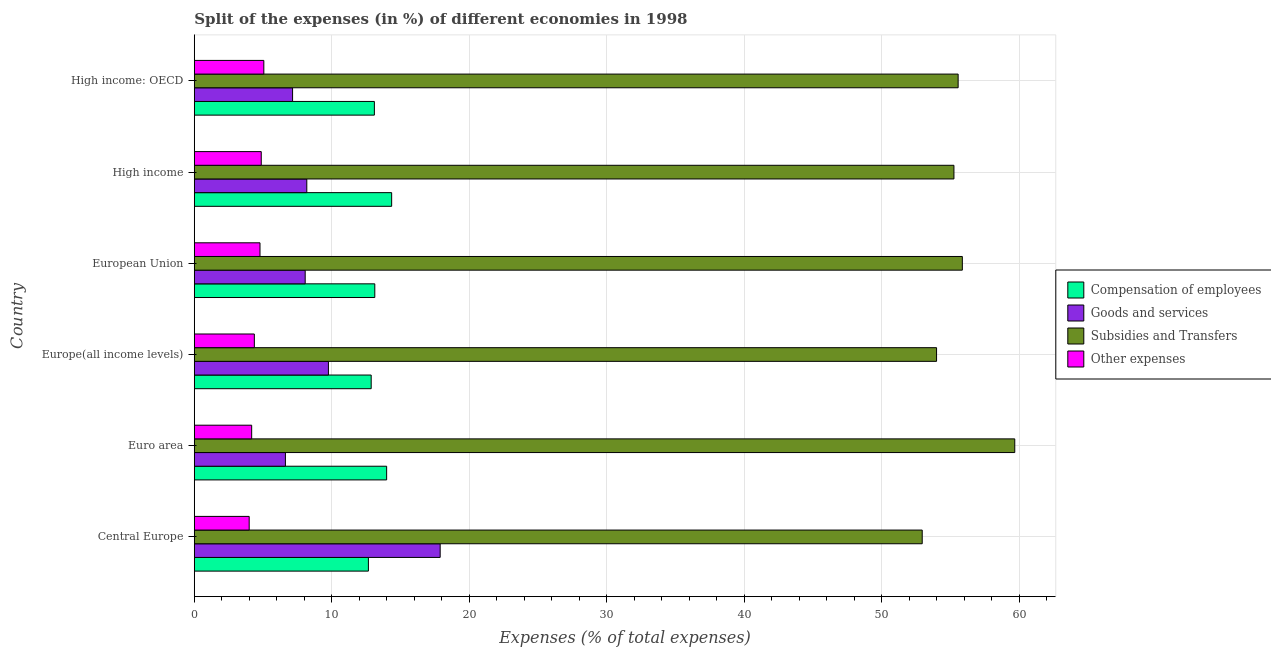How many groups of bars are there?
Offer a very short reply. 6. Are the number of bars per tick equal to the number of legend labels?
Your answer should be very brief. Yes. How many bars are there on the 6th tick from the bottom?
Keep it short and to the point. 4. What is the percentage of amount spent on compensation of employees in Euro area?
Offer a terse response. 13.99. Across all countries, what is the maximum percentage of amount spent on goods and services?
Your answer should be very brief. 17.88. Across all countries, what is the minimum percentage of amount spent on goods and services?
Keep it short and to the point. 6.63. In which country was the percentage of amount spent on other expenses maximum?
Offer a terse response. High income: OECD. In which country was the percentage of amount spent on subsidies minimum?
Make the answer very short. Central Europe. What is the total percentage of amount spent on goods and services in the graph?
Your answer should be compact. 57.67. What is the difference between the percentage of amount spent on subsidies in Central Europe and that in High income?
Offer a very short reply. -2.31. What is the difference between the percentage of amount spent on compensation of employees in Central Europe and the percentage of amount spent on goods and services in European Union?
Ensure brevity in your answer.  4.6. What is the average percentage of amount spent on other expenses per country?
Ensure brevity in your answer.  4.54. What is the difference between the percentage of amount spent on goods and services and percentage of amount spent on compensation of employees in Central Europe?
Offer a terse response. 5.22. What is the ratio of the percentage of amount spent on goods and services in High income to that in High income: OECD?
Make the answer very short. 1.15. What is the difference between the highest and the second highest percentage of amount spent on other expenses?
Your response must be concise. 0.19. What is the difference between the highest and the lowest percentage of amount spent on goods and services?
Give a very brief answer. 11.25. In how many countries, is the percentage of amount spent on subsidies greater than the average percentage of amount spent on subsidies taken over all countries?
Ensure brevity in your answer.  3. What does the 1st bar from the top in Euro area represents?
Ensure brevity in your answer.  Other expenses. What does the 1st bar from the bottom in European Union represents?
Keep it short and to the point. Compensation of employees. Is it the case that in every country, the sum of the percentage of amount spent on compensation of employees and percentage of amount spent on goods and services is greater than the percentage of amount spent on subsidies?
Make the answer very short. No. How many bars are there?
Keep it short and to the point. 24. How many countries are there in the graph?
Offer a terse response. 6. Does the graph contain any zero values?
Provide a short and direct response. No. Does the graph contain grids?
Keep it short and to the point. Yes. What is the title of the graph?
Your answer should be compact. Split of the expenses (in %) of different economies in 1998. Does "Quality of logistic services" appear as one of the legend labels in the graph?
Keep it short and to the point. No. What is the label or title of the X-axis?
Make the answer very short. Expenses (% of total expenses). What is the Expenses (% of total expenses) of Compensation of employees in Central Europe?
Provide a short and direct response. 12.67. What is the Expenses (% of total expenses) of Goods and services in Central Europe?
Ensure brevity in your answer.  17.88. What is the Expenses (% of total expenses) of Subsidies and Transfers in Central Europe?
Your answer should be compact. 52.94. What is the Expenses (% of total expenses) in Other expenses in Central Europe?
Provide a short and direct response. 3.99. What is the Expenses (% of total expenses) in Compensation of employees in Euro area?
Your answer should be compact. 13.99. What is the Expenses (% of total expenses) in Goods and services in Euro area?
Provide a succinct answer. 6.63. What is the Expenses (% of total expenses) in Subsidies and Transfers in Euro area?
Your response must be concise. 59.67. What is the Expenses (% of total expenses) of Other expenses in Euro area?
Offer a very short reply. 4.18. What is the Expenses (% of total expenses) of Compensation of employees in Europe(all income levels)?
Provide a succinct answer. 12.87. What is the Expenses (% of total expenses) in Goods and services in Europe(all income levels)?
Your response must be concise. 9.76. What is the Expenses (% of total expenses) of Subsidies and Transfers in Europe(all income levels)?
Offer a very short reply. 53.99. What is the Expenses (% of total expenses) in Other expenses in Europe(all income levels)?
Give a very brief answer. 4.37. What is the Expenses (% of total expenses) of Compensation of employees in European Union?
Provide a succinct answer. 13.13. What is the Expenses (% of total expenses) in Goods and services in European Union?
Provide a short and direct response. 8.07. What is the Expenses (% of total expenses) of Subsidies and Transfers in European Union?
Make the answer very short. 55.86. What is the Expenses (% of total expenses) in Other expenses in European Union?
Make the answer very short. 4.78. What is the Expenses (% of total expenses) in Compensation of employees in High income?
Your response must be concise. 14.36. What is the Expenses (% of total expenses) in Goods and services in High income?
Make the answer very short. 8.18. What is the Expenses (% of total expenses) of Subsidies and Transfers in High income?
Offer a very short reply. 55.25. What is the Expenses (% of total expenses) in Other expenses in High income?
Provide a short and direct response. 4.87. What is the Expenses (% of total expenses) of Compensation of employees in High income: OECD?
Offer a terse response. 13.1. What is the Expenses (% of total expenses) in Goods and services in High income: OECD?
Give a very brief answer. 7.15. What is the Expenses (% of total expenses) in Subsidies and Transfers in High income: OECD?
Ensure brevity in your answer.  55.56. What is the Expenses (% of total expenses) of Other expenses in High income: OECD?
Offer a very short reply. 5.06. Across all countries, what is the maximum Expenses (% of total expenses) of Compensation of employees?
Your answer should be very brief. 14.36. Across all countries, what is the maximum Expenses (% of total expenses) in Goods and services?
Your answer should be very brief. 17.88. Across all countries, what is the maximum Expenses (% of total expenses) in Subsidies and Transfers?
Give a very brief answer. 59.67. Across all countries, what is the maximum Expenses (% of total expenses) in Other expenses?
Keep it short and to the point. 5.06. Across all countries, what is the minimum Expenses (% of total expenses) in Compensation of employees?
Make the answer very short. 12.67. Across all countries, what is the minimum Expenses (% of total expenses) in Goods and services?
Your answer should be very brief. 6.63. Across all countries, what is the minimum Expenses (% of total expenses) of Subsidies and Transfers?
Keep it short and to the point. 52.94. Across all countries, what is the minimum Expenses (% of total expenses) of Other expenses?
Offer a terse response. 3.99. What is the total Expenses (% of total expenses) of Compensation of employees in the graph?
Offer a very short reply. 80.11. What is the total Expenses (% of total expenses) of Goods and services in the graph?
Your answer should be very brief. 57.67. What is the total Expenses (% of total expenses) in Subsidies and Transfers in the graph?
Your answer should be compact. 333.27. What is the total Expenses (% of total expenses) in Other expenses in the graph?
Ensure brevity in your answer.  27.25. What is the difference between the Expenses (% of total expenses) in Compensation of employees in Central Europe and that in Euro area?
Provide a short and direct response. -1.33. What is the difference between the Expenses (% of total expenses) of Goods and services in Central Europe and that in Euro area?
Provide a short and direct response. 11.25. What is the difference between the Expenses (% of total expenses) of Subsidies and Transfers in Central Europe and that in Euro area?
Provide a succinct answer. -6.73. What is the difference between the Expenses (% of total expenses) in Other expenses in Central Europe and that in Euro area?
Your answer should be very brief. -0.18. What is the difference between the Expenses (% of total expenses) in Compensation of employees in Central Europe and that in Europe(all income levels)?
Make the answer very short. -0.2. What is the difference between the Expenses (% of total expenses) in Goods and services in Central Europe and that in Europe(all income levels)?
Provide a short and direct response. 8.13. What is the difference between the Expenses (% of total expenses) in Subsidies and Transfers in Central Europe and that in Europe(all income levels)?
Provide a short and direct response. -1.04. What is the difference between the Expenses (% of total expenses) in Other expenses in Central Europe and that in Europe(all income levels)?
Provide a short and direct response. -0.38. What is the difference between the Expenses (% of total expenses) of Compensation of employees in Central Europe and that in European Union?
Keep it short and to the point. -0.46. What is the difference between the Expenses (% of total expenses) of Goods and services in Central Europe and that in European Union?
Make the answer very short. 9.82. What is the difference between the Expenses (% of total expenses) of Subsidies and Transfers in Central Europe and that in European Union?
Offer a terse response. -2.92. What is the difference between the Expenses (% of total expenses) in Other expenses in Central Europe and that in European Union?
Your answer should be compact. -0.79. What is the difference between the Expenses (% of total expenses) in Compensation of employees in Central Europe and that in High income?
Provide a succinct answer. -1.69. What is the difference between the Expenses (% of total expenses) of Goods and services in Central Europe and that in High income?
Offer a very short reply. 9.7. What is the difference between the Expenses (% of total expenses) of Subsidies and Transfers in Central Europe and that in High income?
Your answer should be compact. -2.31. What is the difference between the Expenses (% of total expenses) in Other expenses in Central Europe and that in High income?
Your response must be concise. -0.88. What is the difference between the Expenses (% of total expenses) in Compensation of employees in Central Europe and that in High income: OECD?
Your answer should be very brief. -0.43. What is the difference between the Expenses (% of total expenses) of Goods and services in Central Europe and that in High income: OECD?
Your response must be concise. 10.73. What is the difference between the Expenses (% of total expenses) of Subsidies and Transfers in Central Europe and that in High income: OECD?
Provide a short and direct response. -2.61. What is the difference between the Expenses (% of total expenses) of Other expenses in Central Europe and that in High income: OECD?
Make the answer very short. -1.07. What is the difference between the Expenses (% of total expenses) of Compensation of employees in Euro area and that in Europe(all income levels)?
Ensure brevity in your answer.  1.12. What is the difference between the Expenses (% of total expenses) in Goods and services in Euro area and that in Europe(all income levels)?
Make the answer very short. -3.13. What is the difference between the Expenses (% of total expenses) of Subsidies and Transfers in Euro area and that in Europe(all income levels)?
Your response must be concise. 5.69. What is the difference between the Expenses (% of total expenses) in Other expenses in Euro area and that in Europe(all income levels)?
Offer a very short reply. -0.19. What is the difference between the Expenses (% of total expenses) of Compensation of employees in Euro area and that in European Union?
Offer a terse response. 0.86. What is the difference between the Expenses (% of total expenses) of Goods and services in Euro area and that in European Union?
Your response must be concise. -1.44. What is the difference between the Expenses (% of total expenses) of Subsidies and Transfers in Euro area and that in European Union?
Ensure brevity in your answer.  3.81. What is the difference between the Expenses (% of total expenses) of Other expenses in Euro area and that in European Union?
Provide a succinct answer. -0.61. What is the difference between the Expenses (% of total expenses) in Compensation of employees in Euro area and that in High income?
Your answer should be very brief. -0.36. What is the difference between the Expenses (% of total expenses) of Goods and services in Euro area and that in High income?
Offer a terse response. -1.55. What is the difference between the Expenses (% of total expenses) of Subsidies and Transfers in Euro area and that in High income?
Keep it short and to the point. 4.42. What is the difference between the Expenses (% of total expenses) in Other expenses in Euro area and that in High income?
Offer a very short reply. -0.7. What is the difference between the Expenses (% of total expenses) of Compensation of employees in Euro area and that in High income: OECD?
Provide a short and direct response. 0.89. What is the difference between the Expenses (% of total expenses) in Goods and services in Euro area and that in High income: OECD?
Offer a very short reply. -0.52. What is the difference between the Expenses (% of total expenses) of Subsidies and Transfers in Euro area and that in High income: OECD?
Your answer should be compact. 4.12. What is the difference between the Expenses (% of total expenses) in Other expenses in Euro area and that in High income: OECD?
Offer a very short reply. -0.88. What is the difference between the Expenses (% of total expenses) of Compensation of employees in Europe(all income levels) and that in European Union?
Your response must be concise. -0.26. What is the difference between the Expenses (% of total expenses) in Goods and services in Europe(all income levels) and that in European Union?
Offer a terse response. 1.69. What is the difference between the Expenses (% of total expenses) of Subsidies and Transfers in Europe(all income levels) and that in European Union?
Ensure brevity in your answer.  -1.87. What is the difference between the Expenses (% of total expenses) in Other expenses in Europe(all income levels) and that in European Union?
Make the answer very short. -0.41. What is the difference between the Expenses (% of total expenses) in Compensation of employees in Europe(all income levels) and that in High income?
Your answer should be very brief. -1.49. What is the difference between the Expenses (% of total expenses) of Goods and services in Europe(all income levels) and that in High income?
Make the answer very short. 1.57. What is the difference between the Expenses (% of total expenses) of Subsidies and Transfers in Europe(all income levels) and that in High income?
Make the answer very short. -1.26. What is the difference between the Expenses (% of total expenses) in Other expenses in Europe(all income levels) and that in High income?
Provide a short and direct response. -0.5. What is the difference between the Expenses (% of total expenses) in Compensation of employees in Europe(all income levels) and that in High income: OECD?
Offer a very short reply. -0.23. What is the difference between the Expenses (% of total expenses) of Goods and services in Europe(all income levels) and that in High income: OECD?
Offer a very short reply. 2.61. What is the difference between the Expenses (% of total expenses) of Subsidies and Transfers in Europe(all income levels) and that in High income: OECD?
Give a very brief answer. -1.57. What is the difference between the Expenses (% of total expenses) of Other expenses in Europe(all income levels) and that in High income: OECD?
Keep it short and to the point. -0.69. What is the difference between the Expenses (% of total expenses) in Compensation of employees in European Union and that in High income?
Give a very brief answer. -1.23. What is the difference between the Expenses (% of total expenses) of Goods and services in European Union and that in High income?
Make the answer very short. -0.12. What is the difference between the Expenses (% of total expenses) in Subsidies and Transfers in European Union and that in High income?
Offer a very short reply. 0.61. What is the difference between the Expenses (% of total expenses) of Other expenses in European Union and that in High income?
Offer a terse response. -0.09. What is the difference between the Expenses (% of total expenses) in Compensation of employees in European Union and that in High income: OECD?
Your response must be concise. 0.03. What is the difference between the Expenses (% of total expenses) in Goods and services in European Union and that in High income: OECD?
Offer a terse response. 0.92. What is the difference between the Expenses (% of total expenses) of Subsidies and Transfers in European Union and that in High income: OECD?
Ensure brevity in your answer.  0.31. What is the difference between the Expenses (% of total expenses) of Other expenses in European Union and that in High income: OECD?
Offer a very short reply. -0.28. What is the difference between the Expenses (% of total expenses) of Compensation of employees in High income and that in High income: OECD?
Provide a succinct answer. 1.26. What is the difference between the Expenses (% of total expenses) of Goods and services in High income and that in High income: OECD?
Provide a short and direct response. 1.03. What is the difference between the Expenses (% of total expenses) in Subsidies and Transfers in High income and that in High income: OECD?
Your answer should be very brief. -0.31. What is the difference between the Expenses (% of total expenses) in Other expenses in High income and that in High income: OECD?
Make the answer very short. -0.19. What is the difference between the Expenses (% of total expenses) in Compensation of employees in Central Europe and the Expenses (% of total expenses) in Goods and services in Euro area?
Offer a terse response. 6.04. What is the difference between the Expenses (% of total expenses) of Compensation of employees in Central Europe and the Expenses (% of total expenses) of Subsidies and Transfers in Euro area?
Provide a short and direct response. -47.01. What is the difference between the Expenses (% of total expenses) in Compensation of employees in Central Europe and the Expenses (% of total expenses) in Other expenses in Euro area?
Provide a short and direct response. 8.49. What is the difference between the Expenses (% of total expenses) of Goods and services in Central Europe and the Expenses (% of total expenses) of Subsidies and Transfers in Euro area?
Give a very brief answer. -41.79. What is the difference between the Expenses (% of total expenses) in Goods and services in Central Europe and the Expenses (% of total expenses) in Other expenses in Euro area?
Make the answer very short. 13.71. What is the difference between the Expenses (% of total expenses) in Subsidies and Transfers in Central Europe and the Expenses (% of total expenses) in Other expenses in Euro area?
Provide a succinct answer. 48.77. What is the difference between the Expenses (% of total expenses) in Compensation of employees in Central Europe and the Expenses (% of total expenses) in Goods and services in Europe(all income levels)?
Your answer should be compact. 2.91. What is the difference between the Expenses (% of total expenses) of Compensation of employees in Central Europe and the Expenses (% of total expenses) of Subsidies and Transfers in Europe(all income levels)?
Your answer should be compact. -41.32. What is the difference between the Expenses (% of total expenses) in Compensation of employees in Central Europe and the Expenses (% of total expenses) in Other expenses in Europe(all income levels)?
Ensure brevity in your answer.  8.3. What is the difference between the Expenses (% of total expenses) in Goods and services in Central Europe and the Expenses (% of total expenses) in Subsidies and Transfers in Europe(all income levels)?
Keep it short and to the point. -36.1. What is the difference between the Expenses (% of total expenses) of Goods and services in Central Europe and the Expenses (% of total expenses) of Other expenses in Europe(all income levels)?
Offer a terse response. 13.51. What is the difference between the Expenses (% of total expenses) in Subsidies and Transfers in Central Europe and the Expenses (% of total expenses) in Other expenses in Europe(all income levels)?
Offer a terse response. 48.57. What is the difference between the Expenses (% of total expenses) of Compensation of employees in Central Europe and the Expenses (% of total expenses) of Goods and services in European Union?
Offer a terse response. 4.6. What is the difference between the Expenses (% of total expenses) in Compensation of employees in Central Europe and the Expenses (% of total expenses) in Subsidies and Transfers in European Union?
Provide a succinct answer. -43.2. What is the difference between the Expenses (% of total expenses) in Compensation of employees in Central Europe and the Expenses (% of total expenses) in Other expenses in European Union?
Your answer should be compact. 7.88. What is the difference between the Expenses (% of total expenses) in Goods and services in Central Europe and the Expenses (% of total expenses) in Subsidies and Transfers in European Union?
Provide a short and direct response. -37.98. What is the difference between the Expenses (% of total expenses) in Goods and services in Central Europe and the Expenses (% of total expenses) in Other expenses in European Union?
Give a very brief answer. 13.1. What is the difference between the Expenses (% of total expenses) in Subsidies and Transfers in Central Europe and the Expenses (% of total expenses) in Other expenses in European Union?
Provide a short and direct response. 48.16. What is the difference between the Expenses (% of total expenses) of Compensation of employees in Central Europe and the Expenses (% of total expenses) of Goods and services in High income?
Offer a very short reply. 4.48. What is the difference between the Expenses (% of total expenses) in Compensation of employees in Central Europe and the Expenses (% of total expenses) in Subsidies and Transfers in High income?
Keep it short and to the point. -42.58. What is the difference between the Expenses (% of total expenses) of Compensation of employees in Central Europe and the Expenses (% of total expenses) of Other expenses in High income?
Provide a succinct answer. 7.79. What is the difference between the Expenses (% of total expenses) of Goods and services in Central Europe and the Expenses (% of total expenses) of Subsidies and Transfers in High income?
Give a very brief answer. -37.37. What is the difference between the Expenses (% of total expenses) of Goods and services in Central Europe and the Expenses (% of total expenses) of Other expenses in High income?
Give a very brief answer. 13.01. What is the difference between the Expenses (% of total expenses) of Subsidies and Transfers in Central Europe and the Expenses (% of total expenses) of Other expenses in High income?
Give a very brief answer. 48.07. What is the difference between the Expenses (% of total expenses) in Compensation of employees in Central Europe and the Expenses (% of total expenses) in Goods and services in High income: OECD?
Provide a short and direct response. 5.51. What is the difference between the Expenses (% of total expenses) in Compensation of employees in Central Europe and the Expenses (% of total expenses) in Subsidies and Transfers in High income: OECD?
Ensure brevity in your answer.  -42.89. What is the difference between the Expenses (% of total expenses) of Compensation of employees in Central Europe and the Expenses (% of total expenses) of Other expenses in High income: OECD?
Give a very brief answer. 7.61. What is the difference between the Expenses (% of total expenses) of Goods and services in Central Europe and the Expenses (% of total expenses) of Subsidies and Transfers in High income: OECD?
Your answer should be compact. -37.67. What is the difference between the Expenses (% of total expenses) of Goods and services in Central Europe and the Expenses (% of total expenses) of Other expenses in High income: OECD?
Provide a short and direct response. 12.82. What is the difference between the Expenses (% of total expenses) in Subsidies and Transfers in Central Europe and the Expenses (% of total expenses) in Other expenses in High income: OECD?
Keep it short and to the point. 47.88. What is the difference between the Expenses (% of total expenses) in Compensation of employees in Euro area and the Expenses (% of total expenses) in Goods and services in Europe(all income levels)?
Your response must be concise. 4.23. What is the difference between the Expenses (% of total expenses) of Compensation of employees in Euro area and the Expenses (% of total expenses) of Subsidies and Transfers in Europe(all income levels)?
Keep it short and to the point. -39.99. What is the difference between the Expenses (% of total expenses) of Compensation of employees in Euro area and the Expenses (% of total expenses) of Other expenses in Europe(all income levels)?
Offer a terse response. 9.62. What is the difference between the Expenses (% of total expenses) in Goods and services in Euro area and the Expenses (% of total expenses) in Subsidies and Transfers in Europe(all income levels)?
Provide a short and direct response. -47.36. What is the difference between the Expenses (% of total expenses) in Goods and services in Euro area and the Expenses (% of total expenses) in Other expenses in Europe(all income levels)?
Your answer should be compact. 2.26. What is the difference between the Expenses (% of total expenses) in Subsidies and Transfers in Euro area and the Expenses (% of total expenses) in Other expenses in Europe(all income levels)?
Your answer should be compact. 55.3. What is the difference between the Expenses (% of total expenses) of Compensation of employees in Euro area and the Expenses (% of total expenses) of Goods and services in European Union?
Give a very brief answer. 5.92. What is the difference between the Expenses (% of total expenses) of Compensation of employees in Euro area and the Expenses (% of total expenses) of Subsidies and Transfers in European Union?
Offer a terse response. -41.87. What is the difference between the Expenses (% of total expenses) in Compensation of employees in Euro area and the Expenses (% of total expenses) in Other expenses in European Union?
Make the answer very short. 9.21. What is the difference between the Expenses (% of total expenses) of Goods and services in Euro area and the Expenses (% of total expenses) of Subsidies and Transfers in European Union?
Your answer should be very brief. -49.23. What is the difference between the Expenses (% of total expenses) in Goods and services in Euro area and the Expenses (% of total expenses) in Other expenses in European Union?
Make the answer very short. 1.85. What is the difference between the Expenses (% of total expenses) in Subsidies and Transfers in Euro area and the Expenses (% of total expenses) in Other expenses in European Union?
Make the answer very short. 54.89. What is the difference between the Expenses (% of total expenses) of Compensation of employees in Euro area and the Expenses (% of total expenses) of Goods and services in High income?
Offer a terse response. 5.81. What is the difference between the Expenses (% of total expenses) of Compensation of employees in Euro area and the Expenses (% of total expenses) of Subsidies and Transfers in High income?
Give a very brief answer. -41.26. What is the difference between the Expenses (% of total expenses) in Compensation of employees in Euro area and the Expenses (% of total expenses) in Other expenses in High income?
Keep it short and to the point. 9.12. What is the difference between the Expenses (% of total expenses) of Goods and services in Euro area and the Expenses (% of total expenses) of Subsidies and Transfers in High income?
Your answer should be compact. -48.62. What is the difference between the Expenses (% of total expenses) of Goods and services in Euro area and the Expenses (% of total expenses) of Other expenses in High income?
Offer a terse response. 1.76. What is the difference between the Expenses (% of total expenses) in Subsidies and Transfers in Euro area and the Expenses (% of total expenses) in Other expenses in High income?
Your response must be concise. 54.8. What is the difference between the Expenses (% of total expenses) in Compensation of employees in Euro area and the Expenses (% of total expenses) in Goods and services in High income: OECD?
Your answer should be compact. 6.84. What is the difference between the Expenses (% of total expenses) of Compensation of employees in Euro area and the Expenses (% of total expenses) of Subsidies and Transfers in High income: OECD?
Make the answer very short. -41.56. What is the difference between the Expenses (% of total expenses) in Compensation of employees in Euro area and the Expenses (% of total expenses) in Other expenses in High income: OECD?
Make the answer very short. 8.93. What is the difference between the Expenses (% of total expenses) in Goods and services in Euro area and the Expenses (% of total expenses) in Subsidies and Transfers in High income: OECD?
Your answer should be very brief. -48.93. What is the difference between the Expenses (% of total expenses) in Goods and services in Euro area and the Expenses (% of total expenses) in Other expenses in High income: OECD?
Your answer should be very brief. 1.57. What is the difference between the Expenses (% of total expenses) of Subsidies and Transfers in Euro area and the Expenses (% of total expenses) of Other expenses in High income: OECD?
Offer a very short reply. 54.61. What is the difference between the Expenses (% of total expenses) in Compensation of employees in Europe(all income levels) and the Expenses (% of total expenses) in Goods and services in European Union?
Make the answer very short. 4.8. What is the difference between the Expenses (% of total expenses) in Compensation of employees in Europe(all income levels) and the Expenses (% of total expenses) in Subsidies and Transfers in European Union?
Ensure brevity in your answer.  -42.99. What is the difference between the Expenses (% of total expenses) of Compensation of employees in Europe(all income levels) and the Expenses (% of total expenses) of Other expenses in European Union?
Ensure brevity in your answer.  8.09. What is the difference between the Expenses (% of total expenses) of Goods and services in Europe(all income levels) and the Expenses (% of total expenses) of Subsidies and Transfers in European Union?
Provide a succinct answer. -46.1. What is the difference between the Expenses (% of total expenses) in Goods and services in Europe(all income levels) and the Expenses (% of total expenses) in Other expenses in European Union?
Offer a terse response. 4.98. What is the difference between the Expenses (% of total expenses) in Subsidies and Transfers in Europe(all income levels) and the Expenses (% of total expenses) in Other expenses in European Union?
Your response must be concise. 49.21. What is the difference between the Expenses (% of total expenses) of Compensation of employees in Europe(all income levels) and the Expenses (% of total expenses) of Goods and services in High income?
Give a very brief answer. 4.68. What is the difference between the Expenses (% of total expenses) in Compensation of employees in Europe(all income levels) and the Expenses (% of total expenses) in Subsidies and Transfers in High income?
Ensure brevity in your answer.  -42.38. What is the difference between the Expenses (% of total expenses) in Compensation of employees in Europe(all income levels) and the Expenses (% of total expenses) in Other expenses in High income?
Keep it short and to the point. 8. What is the difference between the Expenses (% of total expenses) of Goods and services in Europe(all income levels) and the Expenses (% of total expenses) of Subsidies and Transfers in High income?
Give a very brief answer. -45.49. What is the difference between the Expenses (% of total expenses) of Goods and services in Europe(all income levels) and the Expenses (% of total expenses) of Other expenses in High income?
Your response must be concise. 4.89. What is the difference between the Expenses (% of total expenses) of Subsidies and Transfers in Europe(all income levels) and the Expenses (% of total expenses) of Other expenses in High income?
Your answer should be compact. 49.12. What is the difference between the Expenses (% of total expenses) in Compensation of employees in Europe(all income levels) and the Expenses (% of total expenses) in Goods and services in High income: OECD?
Ensure brevity in your answer.  5.72. What is the difference between the Expenses (% of total expenses) of Compensation of employees in Europe(all income levels) and the Expenses (% of total expenses) of Subsidies and Transfers in High income: OECD?
Give a very brief answer. -42.69. What is the difference between the Expenses (% of total expenses) of Compensation of employees in Europe(all income levels) and the Expenses (% of total expenses) of Other expenses in High income: OECD?
Ensure brevity in your answer.  7.81. What is the difference between the Expenses (% of total expenses) in Goods and services in Europe(all income levels) and the Expenses (% of total expenses) in Subsidies and Transfers in High income: OECD?
Your response must be concise. -45.8. What is the difference between the Expenses (% of total expenses) in Goods and services in Europe(all income levels) and the Expenses (% of total expenses) in Other expenses in High income: OECD?
Your answer should be compact. 4.7. What is the difference between the Expenses (% of total expenses) of Subsidies and Transfers in Europe(all income levels) and the Expenses (% of total expenses) of Other expenses in High income: OECD?
Provide a succinct answer. 48.93. What is the difference between the Expenses (% of total expenses) in Compensation of employees in European Union and the Expenses (% of total expenses) in Goods and services in High income?
Offer a very short reply. 4.94. What is the difference between the Expenses (% of total expenses) of Compensation of employees in European Union and the Expenses (% of total expenses) of Subsidies and Transfers in High income?
Keep it short and to the point. -42.12. What is the difference between the Expenses (% of total expenses) of Compensation of employees in European Union and the Expenses (% of total expenses) of Other expenses in High income?
Ensure brevity in your answer.  8.26. What is the difference between the Expenses (% of total expenses) of Goods and services in European Union and the Expenses (% of total expenses) of Subsidies and Transfers in High income?
Give a very brief answer. -47.18. What is the difference between the Expenses (% of total expenses) of Goods and services in European Union and the Expenses (% of total expenses) of Other expenses in High income?
Provide a succinct answer. 3.2. What is the difference between the Expenses (% of total expenses) in Subsidies and Transfers in European Union and the Expenses (% of total expenses) in Other expenses in High income?
Your answer should be compact. 50.99. What is the difference between the Expenses (% of total expenses) of Compensation of employees in European Union and the Expenses (% of total expenses) of Goods and services in High income: OECD?
Give a very brief answer. 5.98. What is the difference between the Expenses (% of total expenses) in Compensation of employees in European Union and the Expenses (% of total expenses) in Subsidies and Transfers in High income: OECD?
Offer a very short reply. -42.43. What is the difference between the Expenses (% of total expenses) in Compensation of employees in European Union and the Expenses (% of total expenses) in Other expenses in High income: OECD?
Keep it short and to the point. 8.07. What is the difference between the Expenses (% of total expenses) in Goods and services in European Union and the Expenses (% of total expenses) in Subsidies and Transfers in High income: OECD?
Provide a short and direct response. -47.49. What is the difference between the Expenses (% of total expenses) of Goods and services in European Union and the Expenses (% of total expenses) of Other expenses in High income: OECD?
Your response must be concise. 3.01. What is the difference between the Expenses (% of total expenses) of Subsidies and Transfers in European Union and the Expenses (% of total expenses) of Other expenses in High income: OECD?
Provide a succinct answer. 50.8. What is the difference between the Expenses (% of total expenses) of Compensation of employees in High income and the Expenses (% of total expenses) of Goods and services in High income: OECD?
Your response must be concise. 7.21. What is the difference between the Expenses (% of total expenses) of Compensation of employees in High income and the Expenses (% of total expenses) of Subsidies and Transfers in High income: OECD?
Provide a succinct answer. -41.2. What is the difference between the Expenses (% of total expenses) of Compensation of employees in High income and the Expenses (% of total expenses) of Other expenses in High income: OECD?
Make the answer very short. 9.3. What is the difference between the Expenses (% of total expenses) in Goods and services in High income and the Expenses (% of total expenses) in Subsidies and Transfers in High income: OECD?
Provide a short and direct response. -47.37. What is the difference between the Expenses (% of total expenses) in Goods and services in High income and the Expenses (% of total expenses) in Other expenses in High income: OECD?
Make the answer very short. 3.13. What is the difference between the Expenses (% of total expenses) of Subsidies and Transfers in High income and the Expenses (% of total expenses) of Other expenses in High income: OECD?
Your answer should be very brief. 50.19. What is the average Expenses (% of total expenses) in Compensation of employees per country?
Your response must be concise. 13.35. What is the average Expenses (% of total expenses) in Goods and services per country?
Provide a short and direct response. 9.61. What is the average Expenses (% of total expenses) of Subsidies and Transfers per country?
Ensure brevity in your answer.  55.54. What is the average Expenses (% of total expenses) in Other expenses per country?
Give a very brief answer. 4.54. What is the difference between the Expenses (% of total expenses) in Compensation of employees and Expenses (% of total expenses) in Goods and services in Central Europe?
Provide a succinct answer. -5.22. What is the difference between the Expenses (% of total expenses) of Compensation of employees and Expenses (% of total expenses) of Subsidies and Transfers in Central Europe?
Keep it short and to the point. -40.28. What is the difference between the Expenses (% of total expenses) of Compensation of employees and Expenses (% of total expenses) of Other expenses in Central Europe?
Provide a short and direct response. 8.67. What is the difference between the Expenses (% of total expenses) in Goods and services and Expenses (% of total expenses) in Subsidies and Transfers in Central Europe?
Give a very brief answer. -35.06. What is the difference between the Expenses (% of total expenses) of Goods and services and Expenses (% of total expenses) of Other expenses in Central Europe?
Your answer should be very brief. 13.89. What is the difference between the Expenses (% of total expenses) in Subsidies and Transfers and Expenses (% of total expenses) in Other expenses in Central Europe?
Your answer should be compact. 48.95. What is the difference between the Expenses (% of total expenses) of Compensation of employees and Expenses (% of total expenses) of Goods and services in Euro area?
Provide a succinct answer. 7.36. What is the difference between the Expenses (% of total expenses) in Compensation of employees and Expenses (% of total expenses) in Subsidies and Transfers in Euro area?
Ensure brevity in your answer.  -45.68. What is the difference between the Expenses (% of total expenses) in Compensation of employees and Expenses (% of total expenses) in Other expenses in Euro area?
Ensure brevity in your answer.  9.82. What is the difference between the Expenses (% of total expenses) of Goods and services and Expenses (% of total expenses) of Subsidies and Transfers in Euro area?
Keep it short and to the point. -53.04. What is the difference between the Expenses (% of total expenses) in Goods and services and Expenses (% of total expenses) in Other expenses in Euro area?
Your answer should be compact. 2.45. What is the difference between the Expenses (% of total expenses) in Subsidies and Transfers and Expenses (% of total expenses) in Other expenses in Euro area?
Ensure brevity in your answer.  55.5. What is the difference between the Expenses (% of total expenses) in Compensation of employees and Expenses (% of total expenses) in Goods and services in Europe(all income levels)?
Your response must be concise. 3.11. What is the difference between the Expenses (% of total expenses) in Compensation of employees and Expenses (% of total expenses) in Subsidies and Transfers in Europe(all income levels)?
Ensure brevity in your answer.  -41.12. What is the difference between the Expenses (% of total expenses) in Compensation of employees and Expenses (% of total expenses) in Other expenses in Europe(all income levels)?
Ensure brevity in your answer.  8.5. What is the difference between the Expenses (% of total expenses) in Goods and services and Expenses (% of total expenses) in Subsidies and Transfers in Europe(all income levels)?
Offer a terse response. -44.23. What is the difference between the Expenses (% of total expenses) in Goods and services and Expenses (% of total expenses) in Other expenses in Europe(all income levels)?
Your answer should be very brief. 5.39. What is the difference between the Expenses (% of total expenses) in Subsidies and Transfers and Expenses (% of total expenses) in Other expenses in Europe(all income levels)?
Keep it short and to the point. 49.62. What is the difference between the Expenses (% of total expenses) in Compensation of employees and Expenses (% of total expenses) in Goods and services in European Union?
Offer a terse response. 5.06. What is the difference between the Expenses (% of total expenses) of Compensation of employees and Expenses (% of total expenses) of Subsidies and Transfers in European Union?
Provide a succinct answer. -42.73. What is the difference between the Expenses (% of total expenses) in Compensation of employees and Expenses (% of total expenses) in Other expenses in European Union?
Ensure brevity in your answer.  8.35. What is the difference between the Expenses (% of total expenses) in Goods and services and Expenses (% of total expenses) in Subsidies and Transfers in European Union?
Give a very brief answer. -47.79. What is the difference between the Expenses (% of total expenses) in Goods and services and Expenses (% of total expenses) in Other expenses in European Union?
Provide a short and direct response. 3.29. What is the difference between the Expenses (% of total expenses) in Subsidies and Transfers and Expenses (% of total expenses) in Other expenses in European Union?
Your response must be concise. 51.08. What is the difference between the Expenses (% of total expenses) in Compensation of employees and Expenses (% of total expenses) in Goods and services in High income?
Offer a terse response. 6.17. What is the difference between the Expenses (% of total expenses) of Compensation of employees and Expenses (% of total expenses) of Subsidies and Transfers in High income?
Give a very brief answer. -40.89. What is the difference between the Expenses (% of total expenses) of Compensation of employees and Expenses (% of total expenses) of Other expenses in High income?
Give a very brief answer. 9.48. What is the difference between the Expenses (% of total expenses) of Goods and services and Expenses (% of total expenses) of Subsidies and Transfers in High income?
Offer a terse response. -47.07. What is the difference between the Expenses (% of total expenses) of Goods and services and Expenses (% of total expenses) of Other expenses in High income?
Your response must be concise. 3.31. What is the difference between the Expenses (% of total expenses) of Subsidies and Transfers and Expenses (% of total expenses) of Other expenses in High income?
Make the answer very short. 50.38. What is the difference between the Expenses (% of total expenses) in Compensation of employees and Expenses (% of total expenses) in Goods and services in High income: OECD?
Make the answer very short. 5.95. What is the difference between the Expenses (% of total expenses) of Compensation of employees and Expenses (% of total expenses) of Subsidies and Transfers in High income: OECD?
Your answer should be very brief. -42.46. What is the difference between the Expenses (% of total expenses) of Compensation of employees and Expenses (% of total expenses) of Other expenses in High income: OECD?
Your answer should be very brief. 8.04. What is the difference between the Expenses (% of total expenses) of Goods and services and Expenses (% of total expenses) of Subsidies and Transfers in High income: OECD?
Offer a very short reply. -48.4. What is the difference between the Expenses (% of total expenses) in Goods and services and Expenses (% of total expenses) in Other expenses in High income: OECD?
Provide a short and direct response. 2.09. What is the difference between the Expenses (% of total expenses) in Subsidies and Transfers and Expenses (% of total expenses) in Other expenses in High income: OECD?
Keep it short and to the point. 50.5. What is the ratio of the Expenses (% of total expenses) of Compensation of employees in Central Europe to that in Euro area?
Offer a very short reply. 0.91. What is the ratio of the Expenses (% of total expenses) in Goods and services in Central Europe to that in Euro area?
Provide a short and direct response. 2.7. What is the ratio of the Expenses (% of total expenses) of Subsidies and Transfers in Central Europe to that in Euro area?
Provide a short and direct response. 0.89. What is the ratio of the Expenses (% of total expenses) in Other expenses in Central Europe to that in Euro area?
Provide a succinct answer. 0.96. What is the ratio of the Expenses (% of total expenses) of Compensation of employees in Central Europe to that in Europe(all income levels)?
Provide a succinct answer. 0.98. What is the ratio of the Expenses (% of total expenses) of Goods and services in Central Europe to that in Europe(all income levels)?
Offer a very short reply. 1.83. What is the ratio of the Expenses (% of total expenses) in Subsidies and Transfers in Central Europe to that in Europe(all income levels)?
Offer a very short reply. 0.98. What is the ratio of the Expenses (% of total expenses) in Other expenses in Central Europe to that in Europe(all income levels)?
Your response must be concise. 0.91. What is the ratio of the Expenses (% of total expenses) of Compensation of employees in Central Europe to that in European Union?
Your answer should be very brief. 0.96. What is the ratio of the Expenses (% of total expenses) in Goods and services in Central Europe to that in European Union?
Ensure brevity in your answer.  2.22. What is the ratio of the Expenses (% of total expenses) of Subsidies and Transfers in Central Europe to that in European Union?
Make the answer very short. 0.95. What is the ratio of the Expenses (% of total expenses) in Other expenses in Central Europe to that in European Union?
Make the answer very short. 0.84. What is the ratio of the Expenses (% of total expenses) in Compensation of employees in Central Europe to that in High income?
Provide a short and direct response. 0.88. What is the ratio of the Expenses (% of total expenses) in Goods and services in Central Europe to that in High income?
Offer a terse response. 2.19. What is the ratio of the Expenses (% of total expenses) of Subsidies and Transfers in Central Europe to that in High income?
Keep it short and to the point. 0.96. What is the ratio of the Expenses (% of total expenses) of Other expenses in Central Europe to that in High income?
Offer a terse response. 0.82. What is the ratio of the Expenses (% of total expenses) in Compensation of employees in Central Europe to that in High income: OECD?
Give a very brief answer. 0.97. What is the ratio of the Expenses (% of total expenses) in Goods and services in Central Europe to that in High income: OECD?
Give a very brief answer. 2.5. What is the ratio of the Expenses (% of total expenses) of Subsidies and Transfers in Central Europe to that in High income: OECD?
Make the answer very short. 0.95. What is the ratio of the Expenses (% of total expenses) of Other expenses in Central Europe to that in High income: OECD?
Your response must be concise. 0.79. What is the ratio of the Expenses (% of total expenses) in Compensation of employees in Euro area to that in Europe(all income levels)?
Ensure brevity in your answer.  1.09. What is the ratio of the Expenses (% of total expenses) in Goods and services in Euro area to that in Europe(all income levels)?
Ensure brevity in your answer.  0.68. What is the ratio of the Expenses (% of total expenses) in Subsidies and Transfers in Euro area to that in Europe(all income levels)?
Your answer should be compact. 1.11. What is the ratio of the Expenses (% of total expenses) of Other expenses in Euro area to that in Europe(all income levels)?
Give a very brief answer. 0.96. What is the ratio of the Expenses (% of total expenses) in Compensation of employees in Euro area to that in European Union?
Offer a terse response. 1.07. What is the ratio of the Expenses (% of total expenses) of Goods and services in Euro area to that in European Union?
Your answer should be very brief. 0.82. What is the ratio of the Expenses (% of total expenses) in Subsidies and Transfers in Euro area to that in European Union?
Provide a succinct answer. 1.07. What is the ratio of the Expenses (% of total expenses) of Other expenses in Euro area to that in European Union?
Provide a succinct answer. 0.87. What is the ratio of the Expenses (% of total expenses) of Compensation of employees in Euro area to that in High income?
Keep it short and to the point. 0.97. What is the ratio of the Expenses (% of total expenses) in Goods and services in Euro area to that in High income?
Provide a succinct answer. 0.81. What is the ratio of the Expenses (% of total expenses) of Subsidies and Transfers in Euro area to that in High income?
Provide a succinct answer. 1.08. What is the ratio of the Expenses (% of total expenses) in Other expenses in Euro area to that in High income?
Your answer should be very brief. 0.86. What is the ratio of the Expenses (% of total expenses) in Compensation of employees in Euro area to that in High income: OECD?
Keep it short and to the point. 1.07. What is the ratio of the Expenses (% of total expenses) of Goods and services in Euro area to that in High income: OECD?
Provide a short and direct response. 0.93. What is the ratio of the Expenses (% of total expenses) of Subsidies and Transfers in Euro area to that in High income: OECD?
Your answer should be very brief. 1.07. What is the ratio of the Expenses (% of total expenses) in Other expenses in Euro area to that in High income: OECD?
Provide a short and direct response. 0.83. What is the ratio of the Expenses (% of total expenses) of Compensation of employees in Europe(all income levels) to that in European Union?
Make the answer very short. 0.98. What is the ratio of the Expenses (% of total expenses) in Goods and services in Europe(all income levels) to that in European Union?
Your answer should be very brief. 1.21. What is the ratio of the Expenses (% of total expenses) of Subsidies and Transfers in Europe(all income levels) to that in European Union?
Ensure brevity in your answer.  0.97. What is the ratio of the Expenses (% of total expenses) in Other expenses in Europe(all income levels) to that in European Union?
Offer a very short reply. 0.91. What is the ratio of the Expenses (% of total expenses) in Compensation of employees in Europe(all income levels) to that in High income?
Ensure brevity in your answer.  0.9. What is the ratio of the Expenses (% of total expenses) in Goods and services in Europe(all income levels) to that in High income?
Provide a short and direct response. 1.19. What is the ratio of the Expenses (% of total expenses) of Subsidies and Transfers in Europe(all income levels) to that in High income?
Give a very brief answer. 0.98. What is the ratio of the Expenses (% of total expenses) of Other expenses in Europe(all income levels) to that in High income?
Ensure brevity in your answer.  0.9. What is the ratio of the Expenses (% of total expenses) in Compensation of employees in Europe(all income levels) to that in High income: OECD?
Your response must be concise. 0.98. What is the ratio of the Expenses (% of total expenses) in Goods and services in Europe(all income levels) to that in High income: OECD?
Provide a short and direct response. 1.36. What is the ratio of the Expenses (% of total expenses) of Subsidies and Transfers in Europe(all income levels) to that in High income: OECD?
Ensure brevity in your answer.  0.97. What is the ratio of the Expenses (% of total expenses) in Other expenses in Europe(all income levels) to that in High income: OECD?
Ensure brevity in your answer.  0.86. What is the ratio of the Expenses (% of total expenses) in Compensation of employees in European Union to that in High income?
Offer a very short reply. 0.91. What is the ratio of the Expenses (% of total expenses) of Goods and services in European Union to that in High income?
Give a very brief answer. 0.99. What is the ratio of the Expenses (% of total expenses) of Subsidies and Transfers in European Union to that in High income?
Give a very brief answer. 1.01. What is the ratio of the Expenses (% of total expenses) of Other expenses in European Union to that in High income?
Offer a terse response. 0.98. What is the ratio of the Expenses (% of total expenses) of Compensation of employees in European Union to that in High income: OECD?
Make the answer very short. 1. What is the ratio of the Expenses (% of total expenses) of Goods and services in European Union to that in High income: OECD?
Your answer should be compact. 1.13. What is the ratio of the Expenses (% of total expenses) of Subsidies and Transfers in European Union to that in High income: OECD?
Give a very brief answer. 1.01. What is the ratio of the Expenses (% of total expenses) of Other expenses in European Union to that in High income: OECD?
Your answer should be compact. 0.94. What is the ratio of the Expenses (% of total expenses) of Compensation of employees in High income to that in High income: OECD?
Offer a terse response. 1.1. What is the ratio of the Expenses (% of total expenses) of Goods and services in High income to that in High income: OECD?
Give a very brief answer. 1.14. What is the ratio of the Expenses (% of total expenses) in Subsidies and Transfers in High income to that in High income: OECD?
Offer a terse response. 0.99. What is the ratio of the Expenses (% of total expenses) in Other expenses in High income to that in High income: OECD?
Your response must be concise. 0.96. What is the difference between the highest and the second highest Expenses (% of total expenses) in Compensation of employees?
Give a very brief answer. 0.36. What is the difference between the highest and the second highest Expenses (% of total expenses) in Goods and services?
Keep it short and to the point. 8.13. What is the difference between the highest and the second highest Expenses (% of total expenses) in Subsidies and Transfers?
Give a very brief answer. 3.81. What is the difference between the highest and the second highest Expenses (% of total expenses) in Other expenses?
Provide a short and direct response. 0.19. What is the difference between the highest and the lowest Expenses (% of total expenses) in Compensation of employees?
Your response must be concise. 1.69. What is the difference between the highest and the lowest Expenses (% of total expenses) in Goods and services?
Provide a short and direct response. 11.25. What is the difference between the highest and the lowest Expenses (% of total expenses) in Subsidies and Transfers?
Offer a very short reply. 6.73. What is the difference between the highest and the lowest Expenses (% of total expenses) of Other expenses?
Provide a succinct answer. 1.07. 